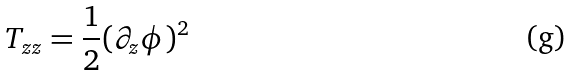<formula> <loc_0><loc_0><loc_500><loc_500>T _ { z z } = \frac { 1 } { 2 } ( \partial _ { z } \phi ) ^ { 2 }</formula> 